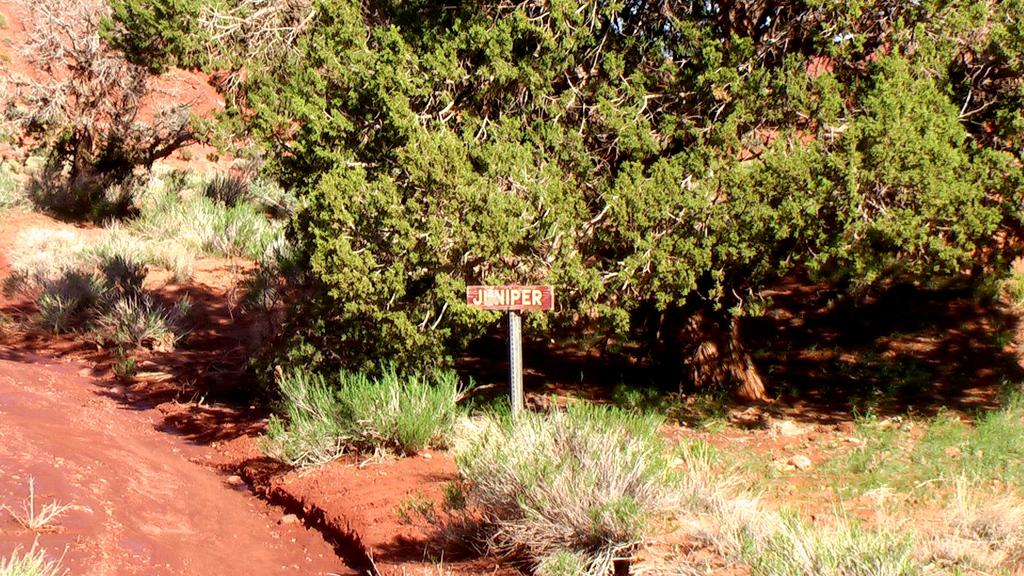What is on the pole in the image? There is a board on a pole in the image. What can be read on the board? There is text on the board. What type of natural environment is depicted in the image? There are trees and plants in the image, as well as mud at the bottom. How many babies are running around in the image? There are no babies present in the image, and therefore no running babies can be observed. 